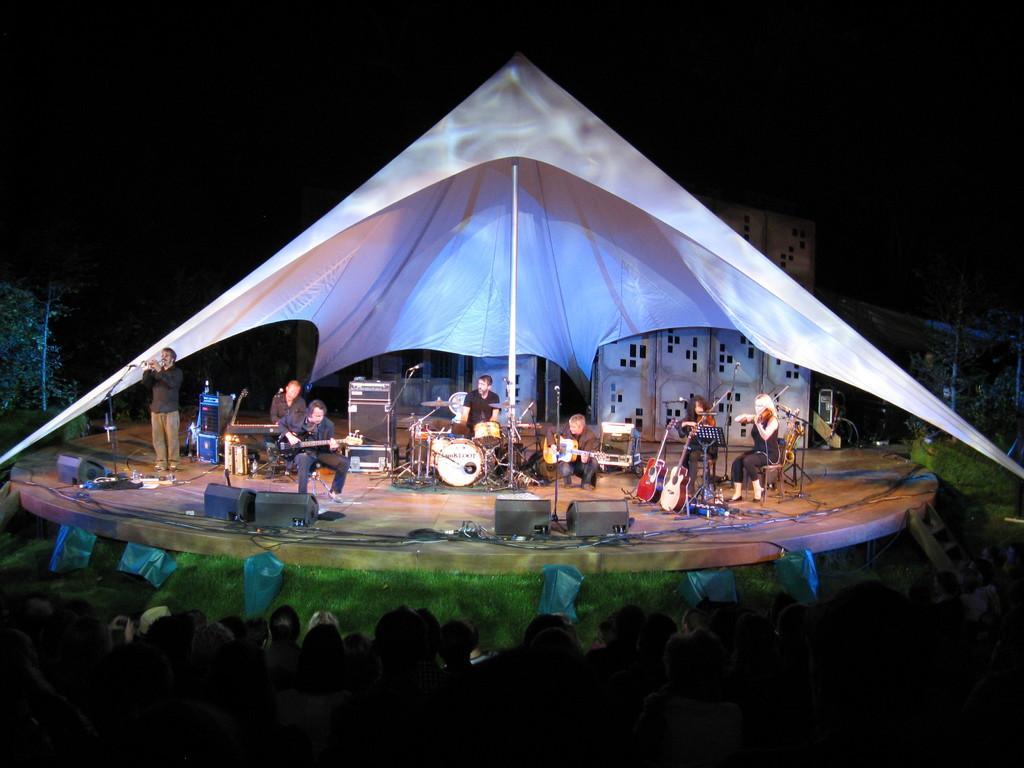Describe this image in one or two sentences. In this image I can see few persons below the stage, few stairs and few persons sitting and a person standing on the stage. I can see few musical instruments, few microphones, few lights and a white colored tent on the stage. I can see few trees and the dark sky in the background. 